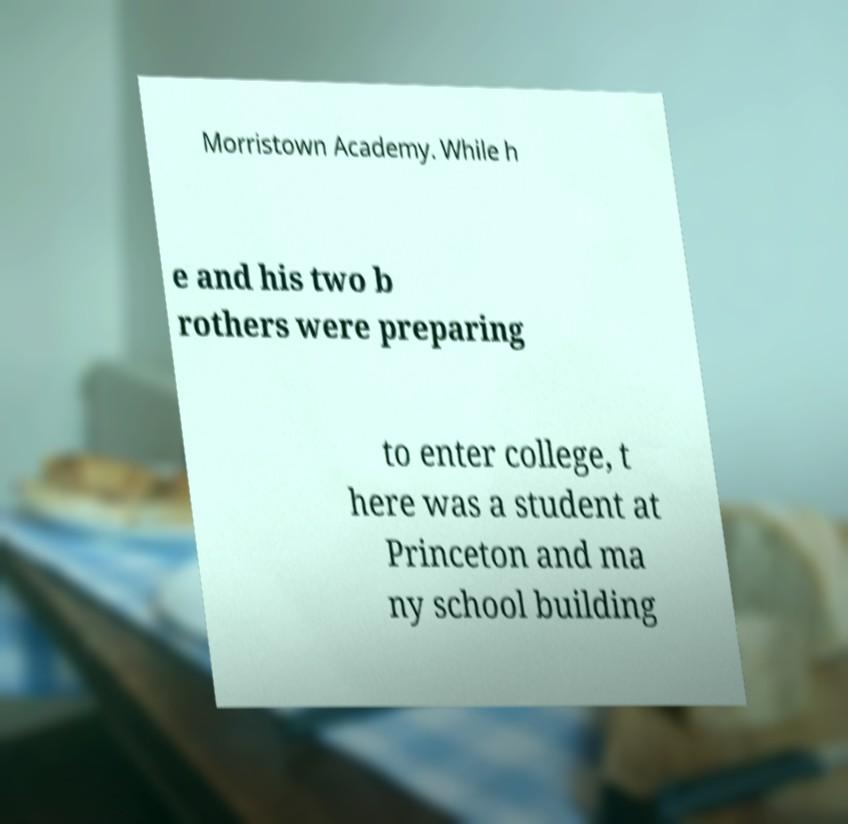Could you assist in decoding the text presented in this image and type it out clearly? Morristown Academy. While h e and his two b rothers were preparing to enter college, t here was a student at Princeton and ma ny school building 